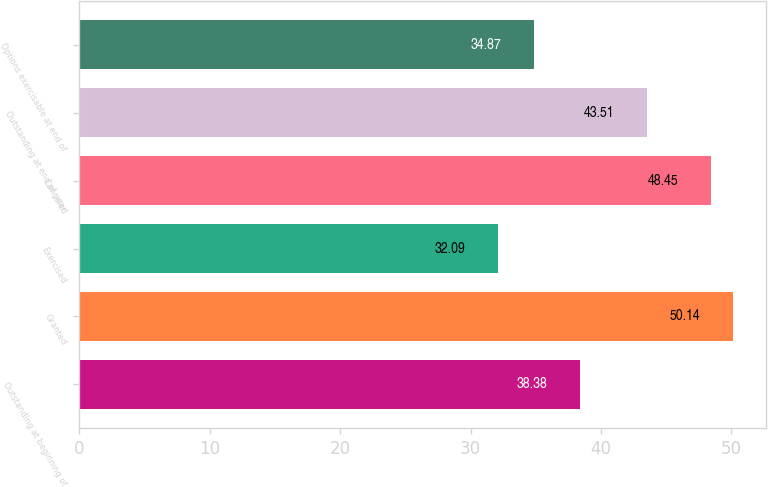Convert chart to OTSL. <chart><loc_0><loc_0><loc_500><loc_500><bar_chart><fcel>Outstanding at beginning of<fcel>Granted<fcel>Exercised<fcel>Canceled<fcel>Outstanding at end of year<fcel>Options exercisable at end of<nl><fcel>38.38<fcel>50.14<fcel>32.09<fcel>48.45<fcel>43.51<fcel>34.87<nl></chart> 